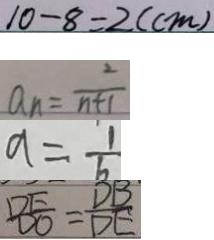<formula> <loc_0><loc_0><loc_500><loc_500>1 0 - 8 = 2 ( c m ) 
 a _ { n } = \frac { 2 } { n + 1 } 
 a = \frac { 1 } { b } 
 \frac { D E } { D O } = \frac { D B } { D E }</formula> 